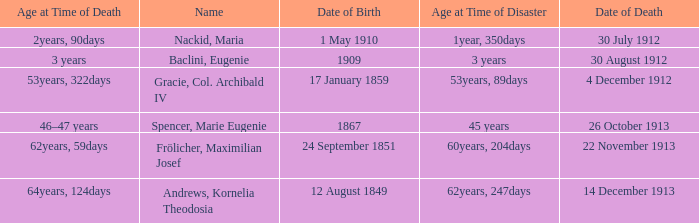When did the person born 24 September 1851 pass away? 22 November 1913. 